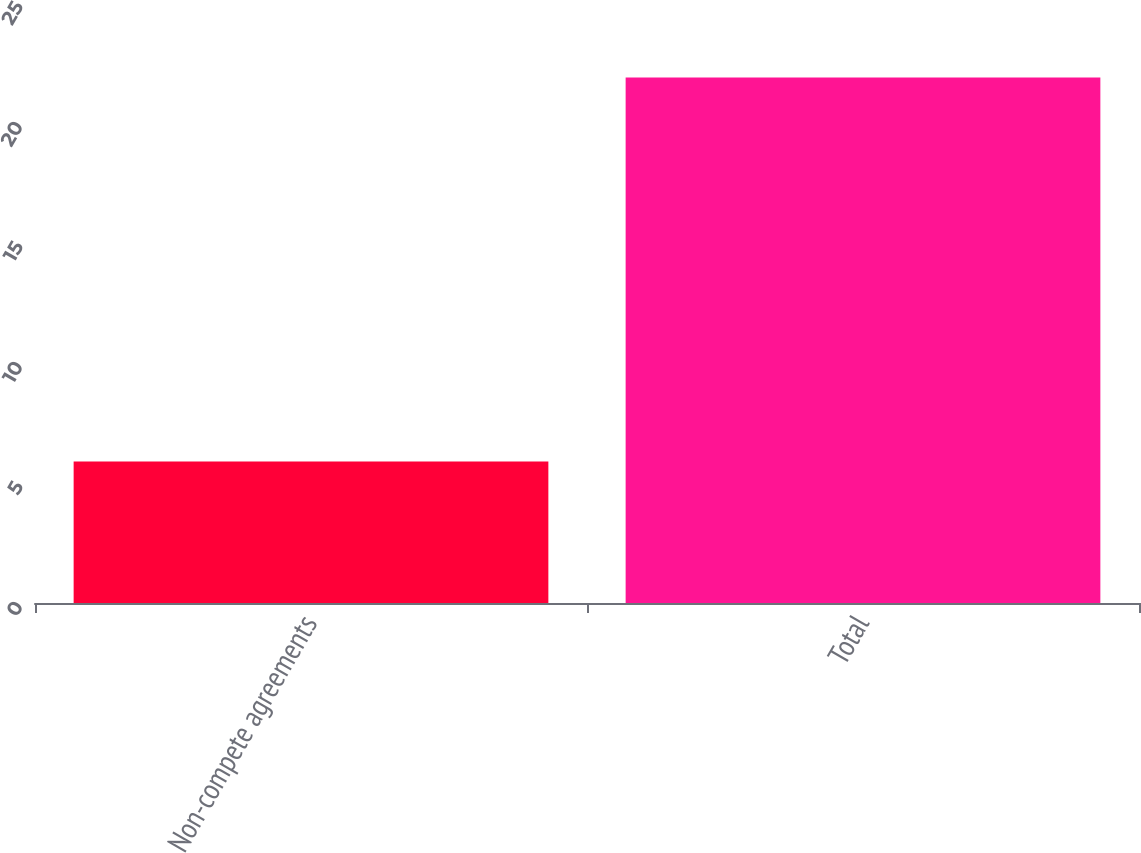Convert chart to OTSL. <chart><loc_0><loc_0><loc_500><loc_500><bar_chart><fcel>Non-compete agreements<fcel>Total<nl><fcel>5.9<fcel>21.9<nl></chart> 